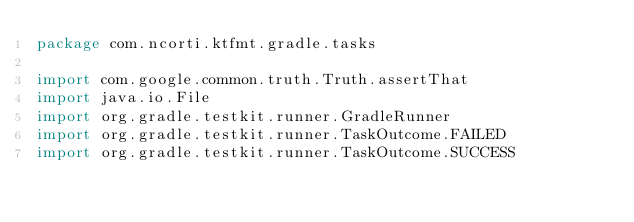Convert code to text. <code><loc_0><loc_0><loc_500><loc_500><_Kotlin_>package com.ncorti.ktfmt.gradle.tasks

import com.google.common.truth.Truth.assertThat
import java.io.File
import org.gradle.testkit.runner.GradleRunner
import org.gradle.testkit.runner.TaskOutcome.FAILED
import org.gradle.testkit.runner.TaskOutcome.SUCCESS</code> 